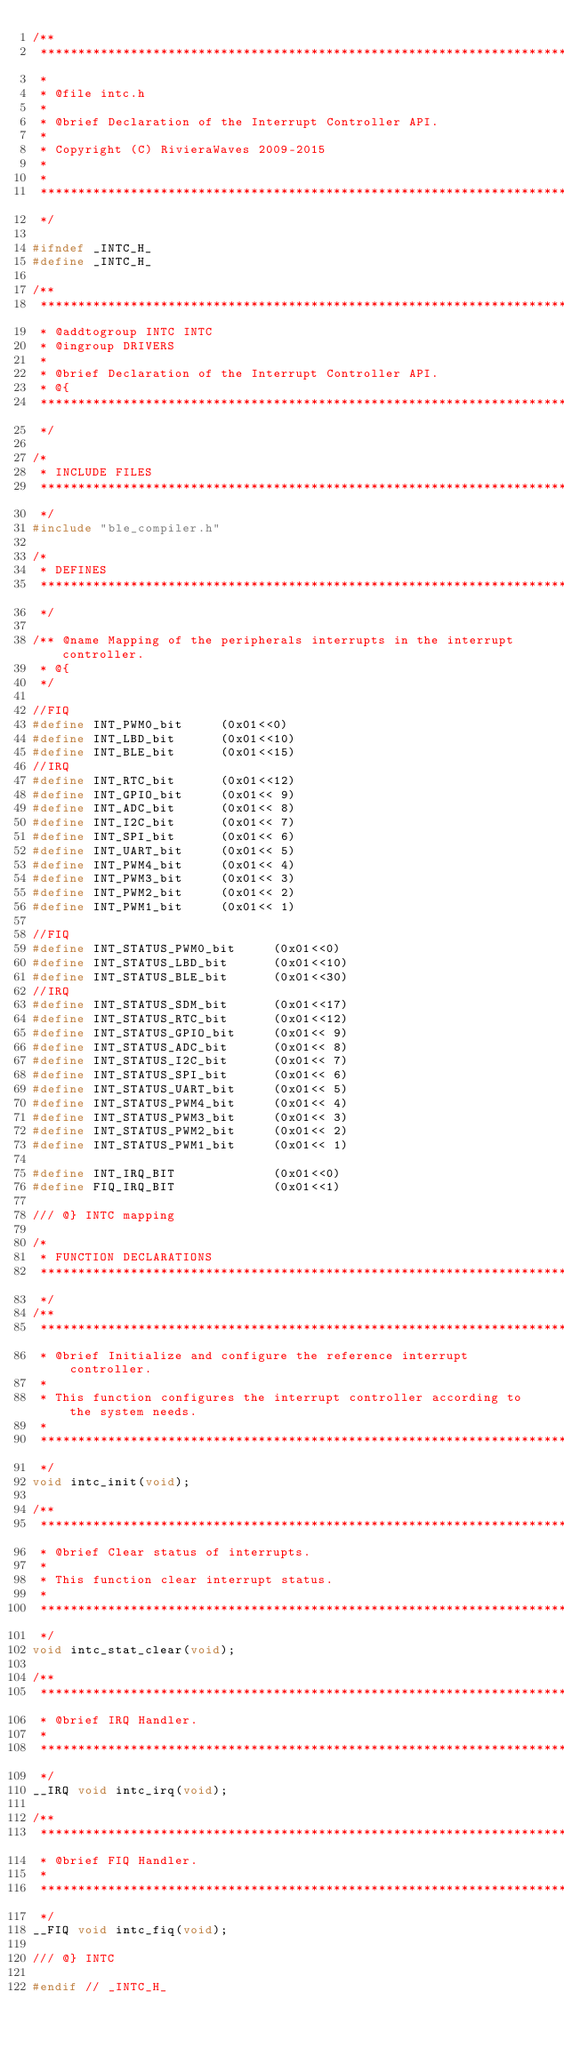Convert code to text. <code><loc_0><loc_0><loc_500><loc_500><_C_>/**
 ****************************************************************************************
 *
 * @file intc.h
 *
 * @brief Declaration of the Interrupt Controller API.
 *
 * Copyright (C) RivieraWaves 2009-2015
 *
 *
 ****************************************************************************************
 */

#ifndef _INTC_H_
#define _INTC_H_

/**
 ****************************************************************************************
 * @addtogroup INTC INTC
 * @ingroup DRIVERS
 *
 * @brief Declaration of the Interrupt Controller API.
 * @{
 ****************************************************************************************
 */

/*
 * INCLUDE FILES
 ****************************************************************************************
 */
#include "ble_compiler.h"

/*
 * DEFINES
 ****************************************************************************************
 */

/** @name Mapping of the peripherals interrupts in the interrupt controller.
 * @{
 */

//FIQ
#define INT_PWM0_bit     (0x01<<0)
#define INT_LBD_bit      (0x01<<10)
#define INT_BLE_bit      (0x01<<15)
//IRQ
#define INT_RTC_bit      (0x01<<12)
#define INT_GPIO_bit     (0x01<< 9)
#define INT_ADC_bit      (0x01<< 8)
#define INT_I2C_bit      (0x01<< 7)
#define INT_SPI_bit      (0x01<< 6)
#define INT_UART_bit     (0x01<< 5)
#define INT_PWM4_bit     (0x01<< 4)
#define INT_PWM3_bit     (0x01<< 3)
#define INT_PWM2_bit     (0x01<< 2)
#define INT_PWM1_bit     (0x01<< 1)

//FIQ
#define INT_STATUS_PWM0_bit     (0x01<<0)
#define INT_STATUS_LBD_bit      (0x01<<10)
#define INT_STATUS_BLE_bit      (0x01<<30)
//IRQ
#define INT_STATUS_SDM_bit      (0x01<<17)
#define INT_STATUS_RTC_bit      (0x01<<12)
#define INT_STATUS_GPIO_bit     (0x01<< 9)
#define INT_STATUS_ADC_bit      (0x01<< 8)
#define INT_STATUS_I2C_bit      (0x01<< 7)
#define INT_STATUS_SPI_bit      (0x01<< 6)
#define INT_STATUS_UART_bit     (0x01<< 5)
#define INT_STATUS_PWM4_bit     (0x01<< 4)
#define INT_STATUS_PWM3_bit     (0x01<< 3)
#define INT_STATUS_PWM2_bit     (0x01<< 2)
#define INT_STATUS_PWM1_bit     (0x01<< 1)

#define INT_IRQ_BIT             (0x01<<0)
#define FIQ_IRQ_BIT             (0x01<<1)

/// @} INTC mapping

/*
 * FUNCTION DECLARATIONS
 ****************************************************************************************
 */
/**
 ****************************************************************************************
 * @brief Initialize and configure the reference interrupt controller.
 *
 * This function configures the interrupt controller according to the system needs.
 *
 ****************************************************************************************
 */
void intc_init(void);

/**
 ****************************************************************************************
 * @brief Clear status of interrupts.
 *
 * This function clear interrupt status.
 *
 ****************************************************************************************
 */
void intc_stat_clear(void);

/**
 ****************************************************************************************
 * @brief IRQ Handler.
 *
 ****************************************************************************************
 */
__IRQ void intc_irq(void);

/**
 ****************************************************************************************
 * @brief FIQ Handler.
 *
 ****************************************************************************************
 */
__FIQ void intc_fiq(void);

/// @} INTC

#endif // _INTC_H_
</code> 